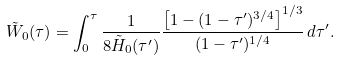Convert formula to latex. <formula><loc_0><loc_0><loc_500><loc_500>\tilde { W } _ { 0 } ( \tau ) = \int _ { 0 } ^ { \tau } \frac { 1 } { 8 \tilde { H } _ { 0 } ( \tau ^ { \prime } ) } \frac { \left [ 1 - ( 1 - \tau ^ { \prime } ) ^ { 3 / 4 } \right ] ^ { 1 / 3 } } { ( 1 - \tau ^ { \prime } ) ^ { 1 / 4 } } \, d \tau ^ { \prime } .</formula> 